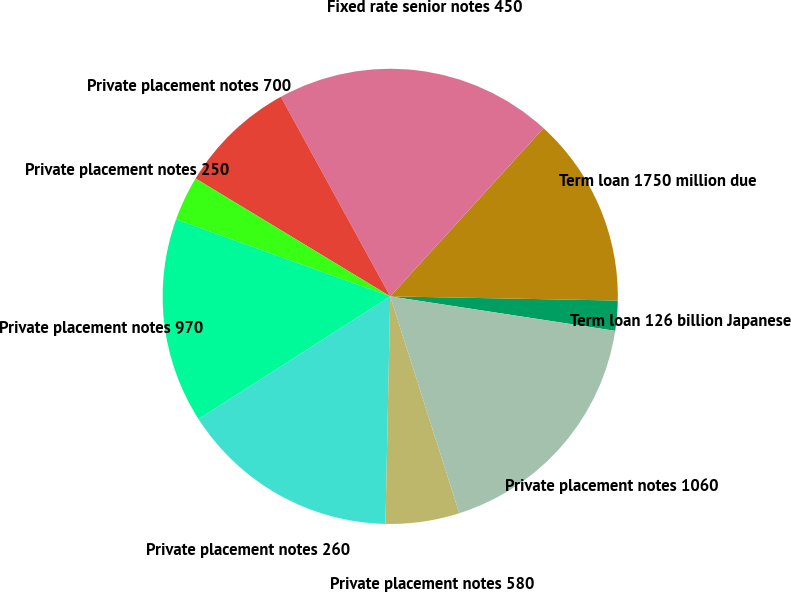<chart> <loc_0><loc_0><loc_500><loc_500><pie_chart><fcel>Term loan 126 billion Japanese<fcel>Term loan 1750 million due<fcel>Fixed rate senior notes 450<fcel>Private placement notes 700<fcel>Private placement notes 250<fcel>Private placement notes 970<fcel>Private placement notes 260<fcel>Private placement notes 580<fcel>Private placement notes 1060<nl><fcel>2.13%<fcel>13.53%<fcel>19.74%<fcel>8.35%<fcel>3.17%<fcel>14.56%<fcel>15.6%<fcel>5.24%<fcel>17.67%<nl></chart> 